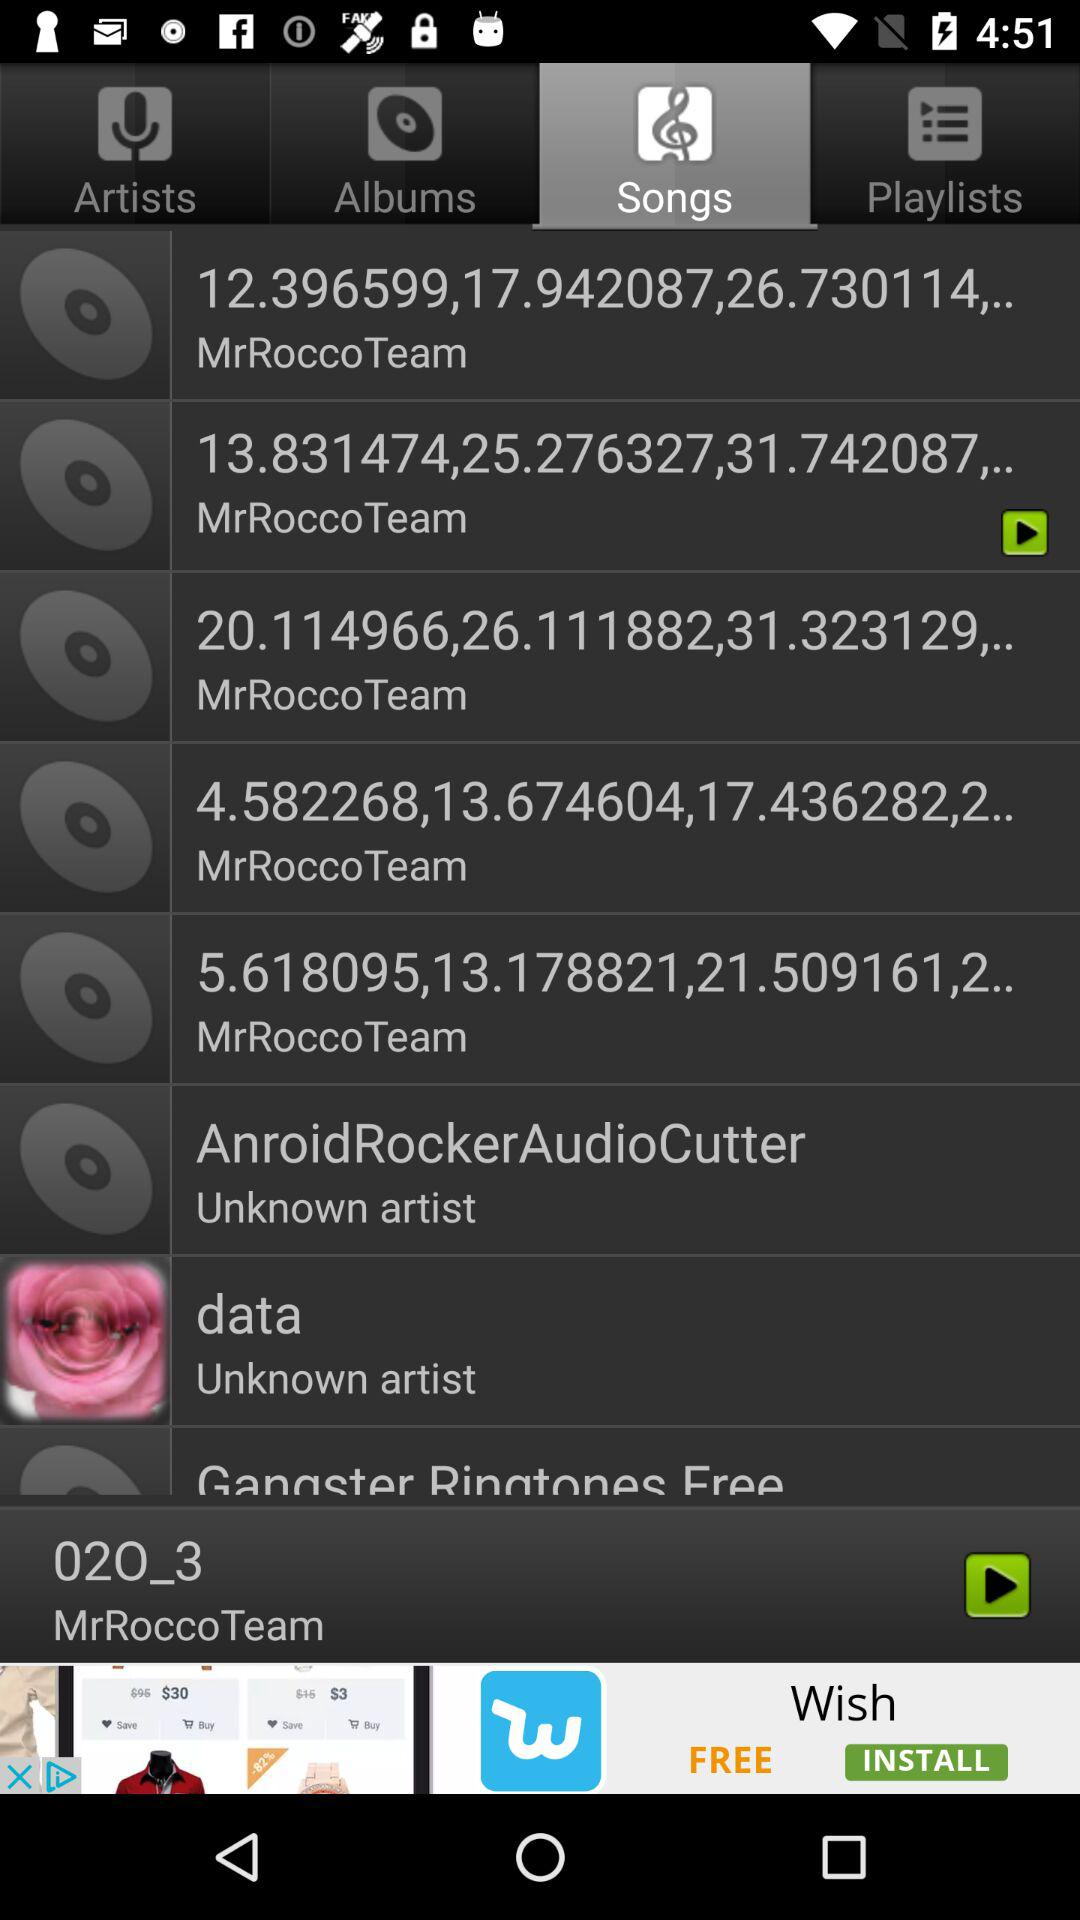What is the name of the artist who has the longest song title?
Answer the question using a single word or phrase. MrRocco Team 